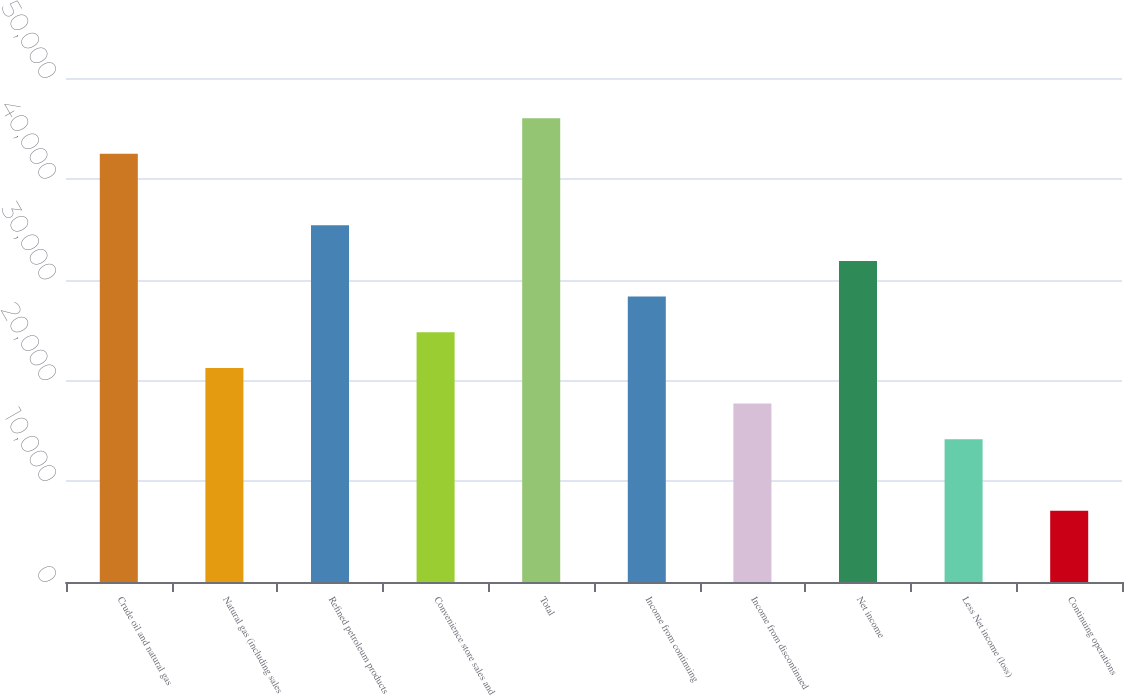<chart> <loc_0><loc_0><loc_500><loc_500><bar_chart><fcel>Crude oil and natural gas<fcel>Natural gas (including sales<fcel>Refined petroleum products<fcel>Convenience store sales and<fcel>Total<fcel>Income from continuing<fcel>Income from discontinued<fcel>Net income<fcel>Less Net income (loss)<fcel>Continuing operations<nl><fcel>42475.1<fcel>21237.8<fcel>35396<fcel>24777.3<fcel>46014.7<fcel>28316.9<fcel>17698.2<fcel>31856.4<fcel>14158.6<fcel>7079.52<nl></chart> 